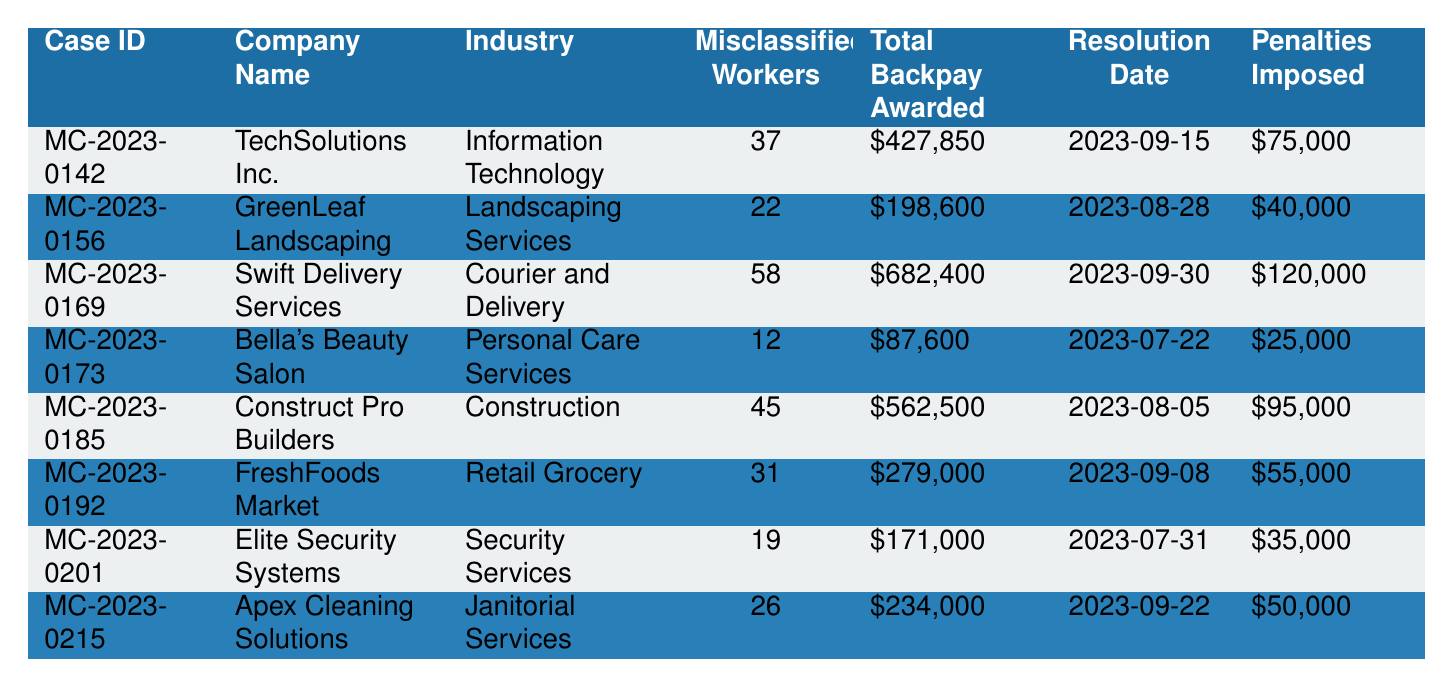What is the total number of misclassified workers across all cases? To find the total number of misclassified workers, add the values: 37 + 22 + 58 + 12 + 45 + 31 + 19 + 26 = 250.
Answer: 250 Which company had the highest total backpay awarded? The maximum total backpay awarded is $682,400 for Swift Delivery Services.
Answer: Swift Delivery Services How many cases had penalties imposed exceeding $70,000? The cases with penalties over $70,000 are MC-2023-0142 ($75,000), MC-2023-0169 ($120,000), and MC-2023-0185 ($95,000). This is a total of 3 cases.
Answer: 3 What is the average total backpay awarded across all cases? First, sum the total backpay: $427,850 + $198,600 + $682,400 + $87,600 + $562,500 + $279,000 + $171,000 + $234,000 = $2,563,950. Then divide this by 8 (the number of cases): $2,563,950 / 8 = $320,493.75.
Answer: $320,493.75 Did any company in the landscaping industry have more than 20 misclassified workers? GreenLeaf Landscaping had 22 misclassified workers, which is greater than 20.
Answer: Yes What is the total amount of penalties imposed across all cases? Add the penalties: $75,000 + $40,000 + $120,000 + $25,000 + $95,000 + $55,000 + $35,000 + $50,000 = $495,000.
Answer: $495,000 Which industry had the least number of misclassified workers? Bella's Beauty Salon in Personal Care Services had the least with 12 misclassified workers.
Answer: Personal Care Services How many workers were misclassified in the construction industry? The data shows that Construct Pro Builders had 45 misclassified workers in the construction industry.
Answer: 45 What was the total backpay for the retail grocery sector? For FreshFoods Market, the total backpay awarded is $279,000; this is the only case in the retail grocery sector.
Answer: $279,000 Which case was resolved first based on the resolution date? The earliest resolution date is 2023-07-22 for Bella's Beauty Salon (MC-2023-0173).
Answer: Bella's Beauty Salon How many industries had cases with misclassified workers exceeding 30? The industries with cases exceeding 30 misclassified workers are Information Technology (37), Courier and Delivery (58), Construction (45), and Retail Grocery (31). This totals 4 industries.
Answer: 4 